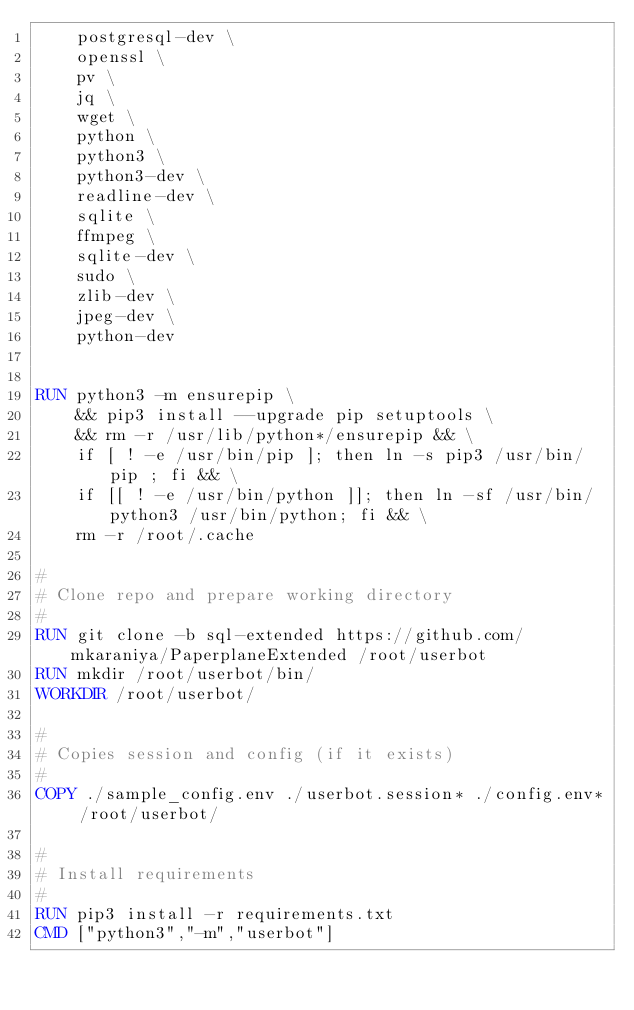Convert code to text. <code><loc_0><loc_0><loc_500><loc_500><_Dockerfile_>    postgresql-dev \
    openssl \
    pv \
    jq \
    wget \
    python \
    python3 \
    python3-dev \
    readline-dev \
    sqlite \
    ffmpeg \
    sqlite-dev \
    sudo \
    zlib-dev \
    jpeg-dev \
    python-dev


RUN python3 -m ensurepip \
    && pip3 install --upgrade pip setuptools \
    && rm -r /usr/lib/python*/ensurepip && \
    if [ ! -e /usr/bin/pip ]; then ln -s pip3 /usr/bin/pip ; fi && \
    if [[ ! -e /usr/bin/python ]]; then ln -sf /usr/bin/python3 /usr/bin/python; fi && \
    rm -r /root/.cache

#
# Clone repo and prepare working directory
#
RUN git clone -b sql-extended https://github.com/mkaraniya/PaperplaneExtended /root/userbot
RUN mkdir /root/userbot/bin/
WORKDIR /root/userbot/

#
# Copies session and config (if it exists)
#
COPY ./sample_config.env ./userbot.session* ./config.env* /root/userbot/

#
# Install requirements
#
RUN pip3 install -r requirements.txt
CMD ["python3","-m","userbot"]
</code> 